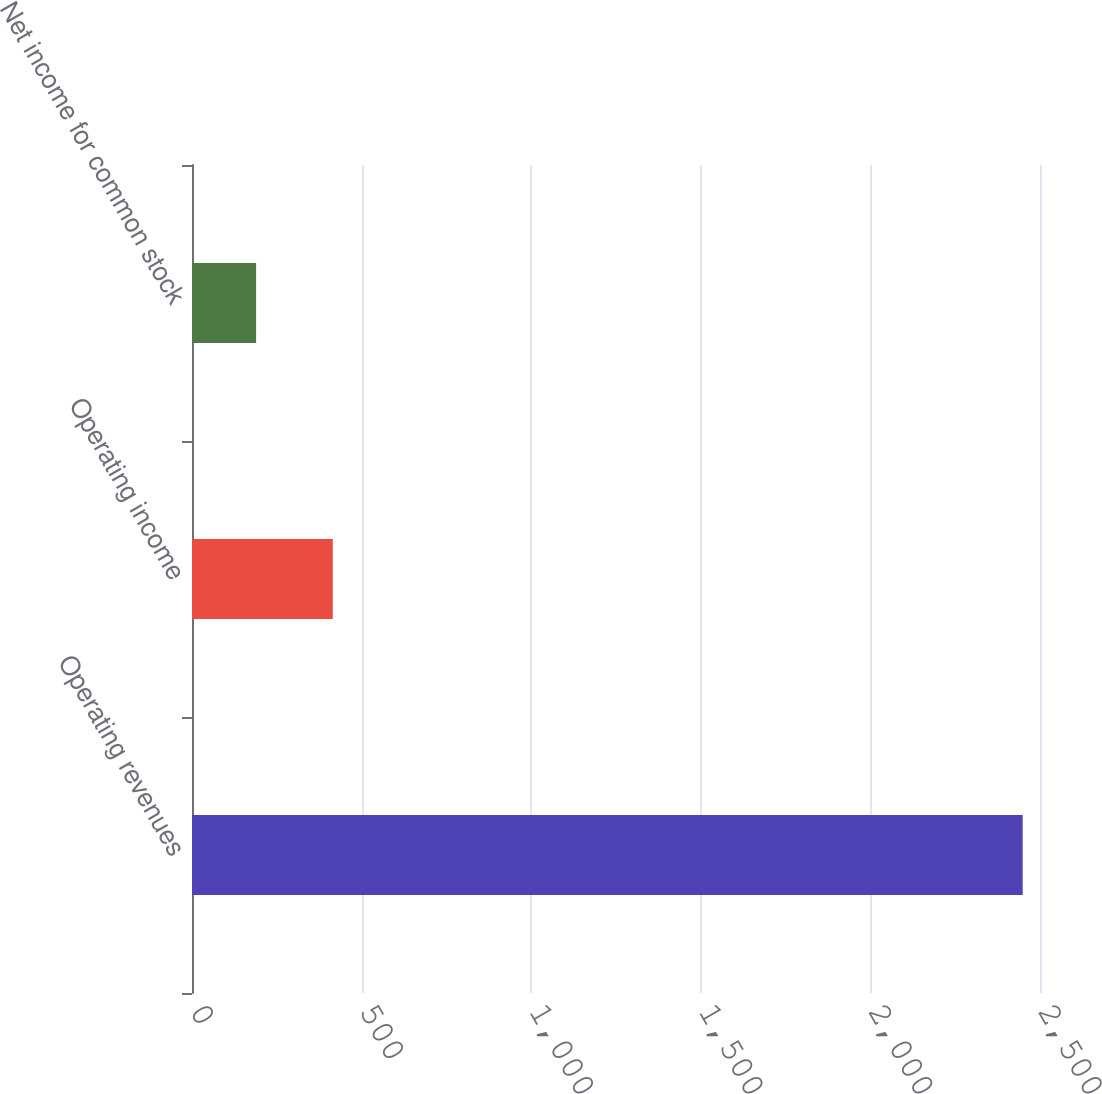Convert chart. <chart><loc_0><loc_0><loc_500><loc_500><bar_chart><fcel>Operating revenues<fcel>Operating income<fcel>Net income for common stock<nl><fcel>2449<fcel>415<fcel>189<nl></chart> 